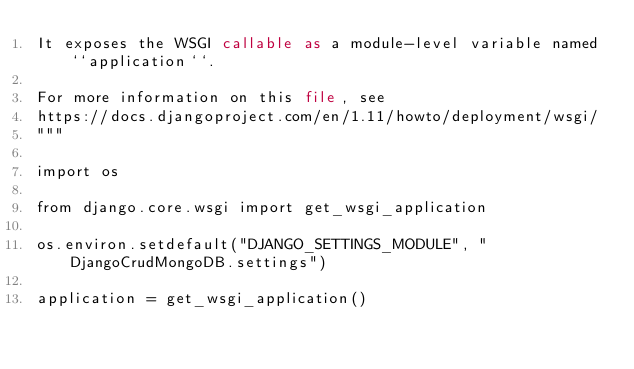<code> <loc_0><loc_0><loc_500><loc_500><_Python_>It exposes the WSGI callable as a module-level variable named ``application``.

For more information on this file, see
https://docs.djangoproject.com/en/1.11/howto/deployment/wsgi/
"""

import os

from django.core.wsgi import get_wsgi_application

os.environ.setdefault("DJANGO_SETTINGS_MODULE", "DjangoCrudMongoDB.settings")

application = get_wsgi_application()
</code> 